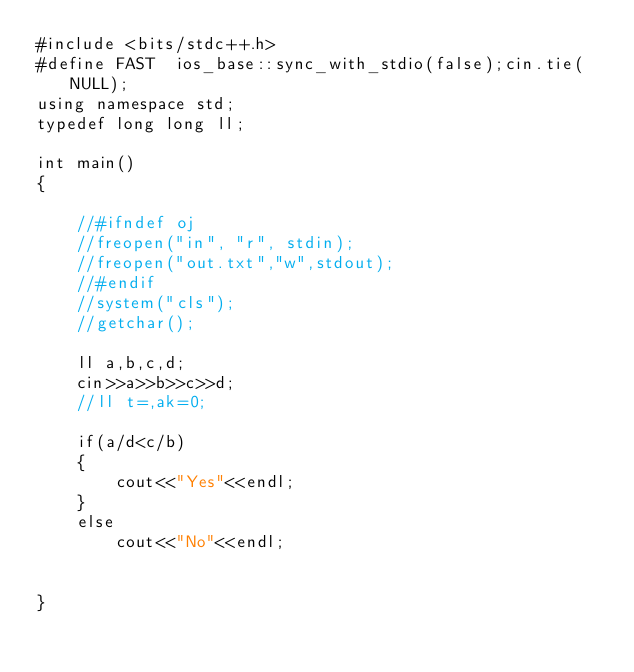<code> <loc_0><loc_0><loc_500><loc_500><_C++_>#include <bits/stdc++.h>
#define FAST  ios_base::sync_with_stdio(false);cin.tie(NULL);
using namespace std;
typedef long long ll;

int main()
{

    //#ifndef oj
    //freopen("in", "r", stdin);
    //freopen("out.txt","w",stdout);
    //#endif
    //system("cls");
    //getchar();

    ll a,b,c,d;
    cin>>a>>b>>c>>d;
    //ll t=,ak=0;

    if(a/d<c/b)
    {
        cout<<"Yes"<<endl;
    }
    else
        cout<<"No"<<endl;


}
</code> 